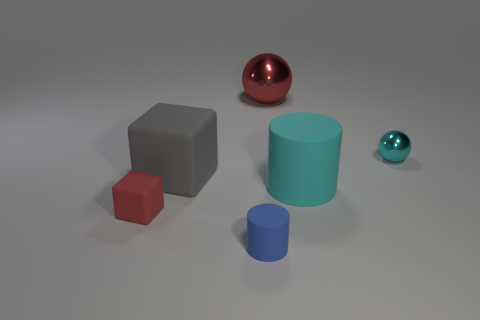Are there more large red spheres that are in front of the blue cylinder than large cylinders that are in front of the large gray object?
Your answer should be compact. No. What is the material of the blue thing that is the same size as the red rubber object?
Ensure brevity in your answer.  Rubber. What is the shape of the large gray rubber object?
Offer a very short reply. Cube. How many red objects are either cylinders or small blocks?
Ensure brevity in your answer.  1. There is a cube that is the same material as the gray thing; what size is it?
Provide a short and direct response. Small. Does the tiny object behind the large gray cube have the same material as the red object that is to the left of the big red metal thing?
Make the answer very short. No. How many balls are either large gray things or small cyan objects?
Your answer should be very brief. 1. There is a tiny cyan ball that is behind the rubber object left of the gray matte block; how many spheres are to the left of it?
Offer a terse response. 1. What is the material of the large cyan thing that is the same shape as the small blue matte object?
Your answer should be very brief. Rubber. Are there any other things that have the same material as the large red ball?
Offer a terse response. Yes. 